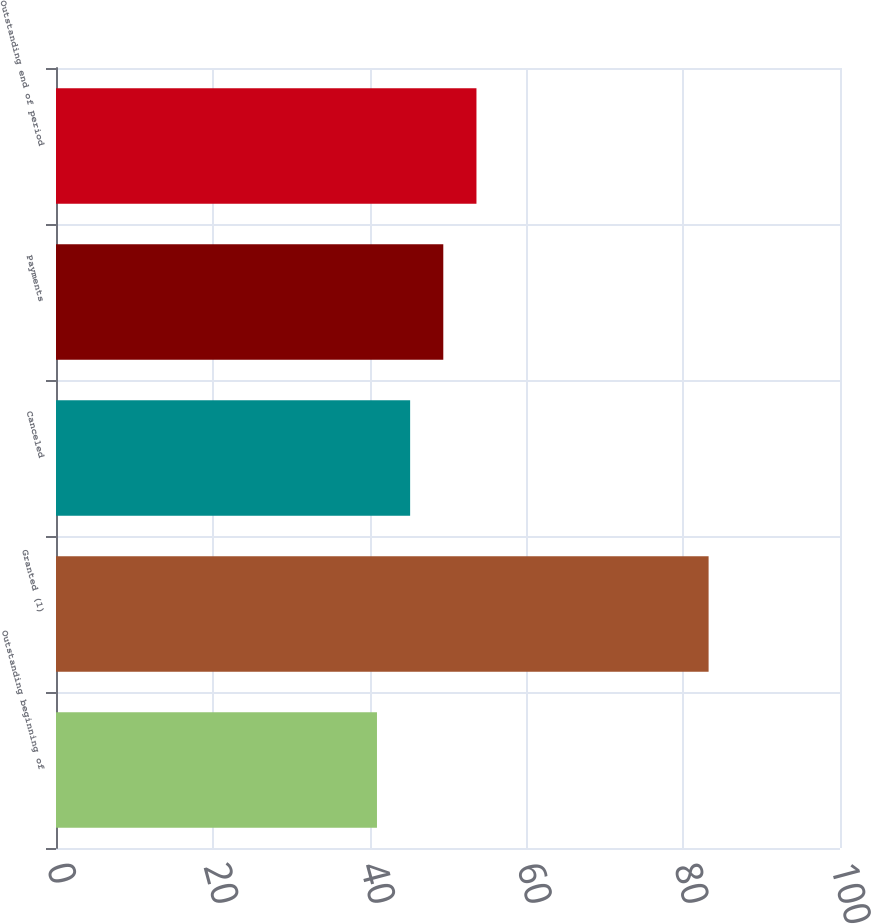Convert chart to OTSL. <chart><loc_0><loc_0><loc_500><loc_500><bar_chart><fcel>Outstanding beginning of<fcel>Granted (1)<fcel>Canceled<fcel>Payments<fcel>Outstanding end of period<nl><fcel>40.94<fcel>83.24<fcel>45.17<fcel>49.4<fcel>53.63<nl></chart> 